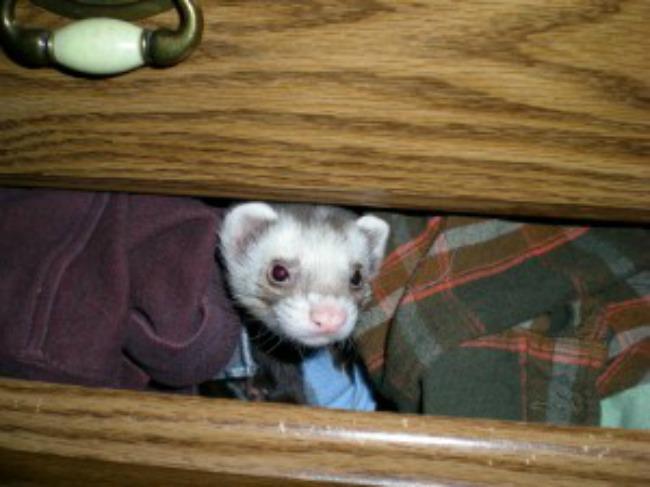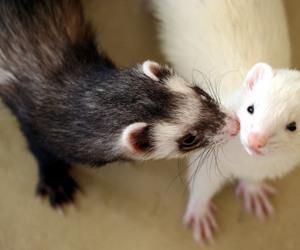The first image is the image on the left, the second image is the image on the right. Evaluate the accuracy of this statement regarding the images: "The left image contains a ferret resting its head on another ferrets neck.". Is it true? Answer yes or no. No. The first image is the image on the left, the second image is the image on the right. Considering the images on both sides, is "One or more ferrets is being held by a human in each photo." valid? Answer yes or no. No. 